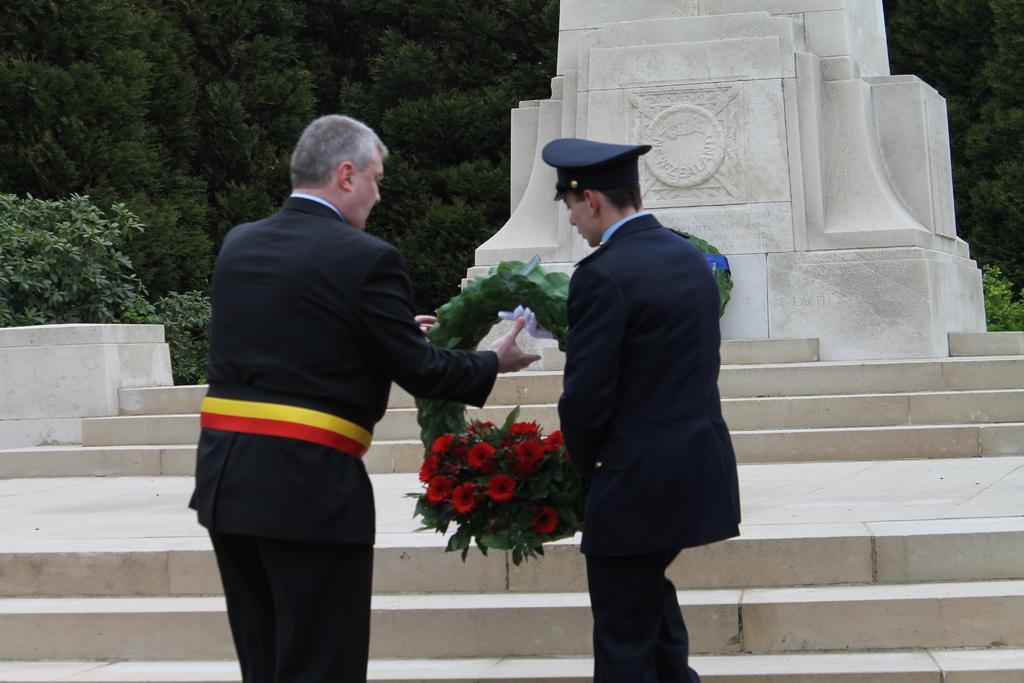Can you describe this image briefly? In the middle of the image two persons are standing and holding a bouquet. In front of them we can see some steps and sculpture. Behind them we can see some trees. 